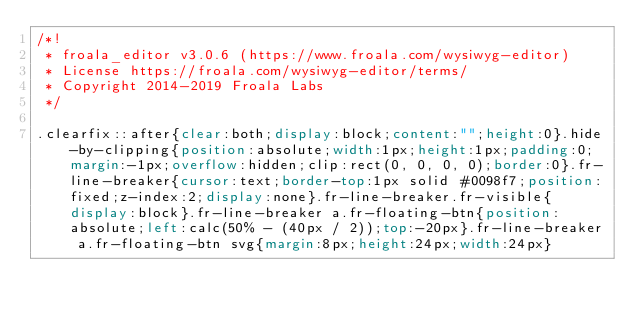Convert code to text. <code><loc_0><loc_0><loc_500><loc_500><_CSS_>/*!
 * froala_editor v3.0.6 (https://www.froala.com/wysiwyg-editor)
 * License https://froala.com/wysiwyg-editor/terms/
 * Copyright 2014-2019 Froala Labs
 */

.clearfix::after{clear:both;display:block;content:"";height:0}.hide-by-clipping{position:absolute;width:1px;height:1px;padding:0;margin:-1px;overflow:hidden;clip:rect(0, 0, 0, 0);border:0}.fr-line-breaker{cursor:text;border-top:1px solid #0098f7;position:fixed;z-index:2;display:none}.fr-line-breaker.fr-visible{display:block}.fr-line-breaker a.fr-floating-btn{position:absolute;left:calc(50% - (40px / 2));top:-20px}.fr-line-breaker a.fr-floating-btn svg{margin:8px;height:24px;width:24px}
</code> 